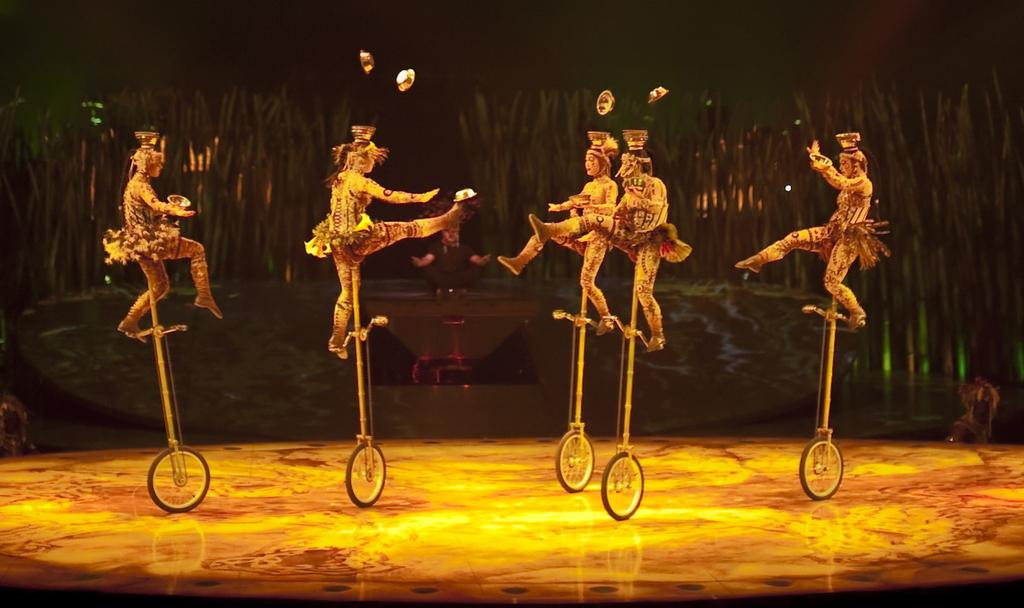Who or what is present in the image? There are people in the image. What are the people doing in the image? The people are on unicycles. What are the people wearing in the image? The people are wearing costumes. What are the people holding in the image? The people are holding objects. What else can be seen in the image besides the people? There are objects in the air in the image. What type of debt is being discussed in the image? There is no mention of debt in the image; it features people on unicycles wearing costumes and holding objects. What kind of prose is being written by the people in the image? There is no indication that the people in the image are writing prose; they are on unicycles and holding objects. 